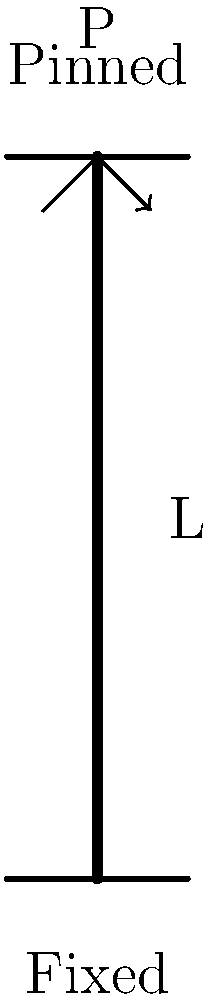In the context of column buckling analysis, consider a column with a fixed base and a pinned top, as shown in the figure. The column has a length L and a flexural rigidity EI. What is the expression for the critical buckling load (P_cr) for this column? To determine the critical buckling load for a column with different end conditions, we follow these steps:

1. Identify the end conditions: In this case, we have a fixed base and a pinned top.

2. Determine the effective length factor (K):
   - For a fixed-pinned column, K = 0.699

3. Recall Euler's formula for critical buckling load:
   $$P_{cr} = \frac{\pi^2 EI}{(KL)^2}$$

   Where:
   - E is the modulus of elasticity
   - I is the moment of inertia of the cross-section
   - L is the actual length of the column
   - K is the effective length factor

4. Substitute the K value for the fixed-pinned condition:
   $$P_{cr} = \frac{\pi^2 EI}{(0.699L)^2}$$

5. Simplify the expression:
   $$P_{cr} = \frac{\pi^2 EI}{0.488601L^2}$$

6. Further simplification:
   $$P_{cr} \approx \frac{20.19 EI}{L^2}$$

This final expression represents the critical buckling load for a column with a fixed base and a pinned top.
Answer: $$P_{cr} \approx \frac{20.19 EI}{L^2}$$ 